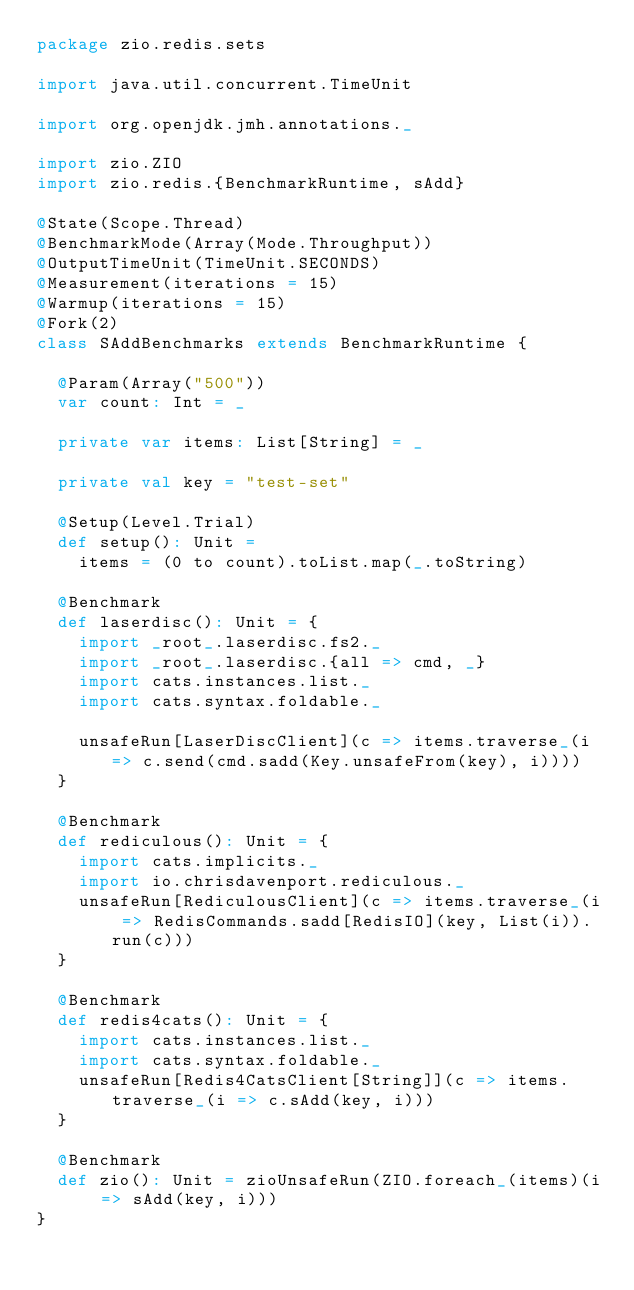Convert code to text. <code><loc_0><loc_0><loc_500><loc_500><_Scala_>package zio.redis.sets

import java.util.concurrent.TimeUnit

import org.openjdk.jmh.annotations._

import zio.ZIO
import zio.redis.{BenchmarkRuntime, sAdd}

@State(Scope.Thread)
@BenchmarkMode(Array(Mode.Throughput))
@OutputTimeUnit(TimeUnit.SECONDS)
@Measurement(iterations = 15)
@Warmup(iterations = 15)
@Fork(2)
class SAddBenchmarks extends BenchmarkRuntime {

  @Param(Array("500"))
  var count: Int = _

  private var items: List[String] = _

  private val key = "test-set"

  @Setup(Level.Trial)
  def setup(): Unit =
    items = (0 to count).toList.map(_.toString)

  @Benchmark
  def laserdisc(): Unit = {
    import _root_.laserdisc.fs2._
    import _root_.laserdisc.{all => cmd, _}
    import cats.instances.list._
    import cats.syntax.foldable._

    unsafeRun[LaserDiscClient](c => items.traverse_(i => c.send(cmd.sadd(Key.unsafeFrom(key), i))))
  }

  @Benchmark
  def rediculous(): Unit = {
    import cats.implicits._
    import io.chrisdavenport.rediculous._
    unsafeRun[RediculousClient](c => items.traverse_(i => RedisCommands.sadd[RedisIO](key, List(i)).run(c)))
  }

  @Benchmark
  def redis4cats(): Unit = {
    import cats.instances.list._
    import cats.syntax.foldable._
    unsafeRun[Redis4CatsClient[String]](c => items.traverse_(i => c.sAdd(key, i)))
  }

  @Benchmark
  def zio(): Unit = zioUnsafeRun(ZIO.foreach_(items)(i => sAdd(key, i)))
}
</code> 